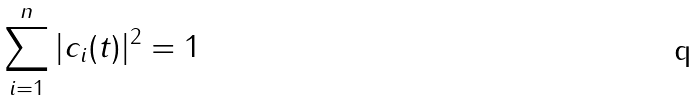<formula> <loc_0><loc_0><loc_500><loc_500>\sum _ { i = 1 } ^ { n } | c _ { i } ( t ) | ^ { 2 } = 1</formula> 